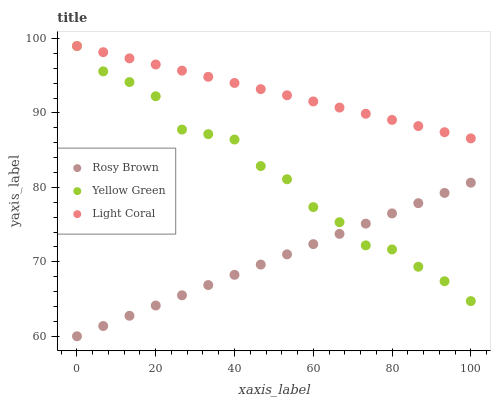Does Rosy Brown have the minimum area under the curve?
Answer yes or no. Yes. Does Light Coral have the maximum area under the curve?
Answer yes or no. Yes. Does Yellow Green have the minimum area under the curve?
Answer yes or no. No. Does Yellow Green have the maximum area under the curve?
Answer yes or no. No. Is Light Coral the smoothest?
Answer yes or no. Yes. Is Yellow Green the roughest?
Answer yes or no. Yes. Is Rosy Brown the smoothest?
Answer yes or no. No. Is Rosy Brown the roughest?
Answer yes or no. No. Does Rosy Brown have the lowest value?
Answer yes or no. Yes. Does Yellow Green have the lowest value?
Answer yes or no. No. Does Yellow Green have the highest value?
Answer yes or no. Yes. Does Rosy Brown have the highest value?
Answer yes or no. No. Is Rosy Brown less than Light Coral?
Answer yes or no. Yes. Is Light Coral greater than Rosy Brown?
Answer yes or no. Yes. Does Rosy Brown intersect Yellow Green?
Answer yes or no. Yes. Is Rosy Brown less than Yellow Green?
Answer yes or no. No. Is Rosy Brown greater than Yellow Green?
Answer yes or no. No. Does Rosy Brown intersect Light Coral?
Answer yes or no. No. 